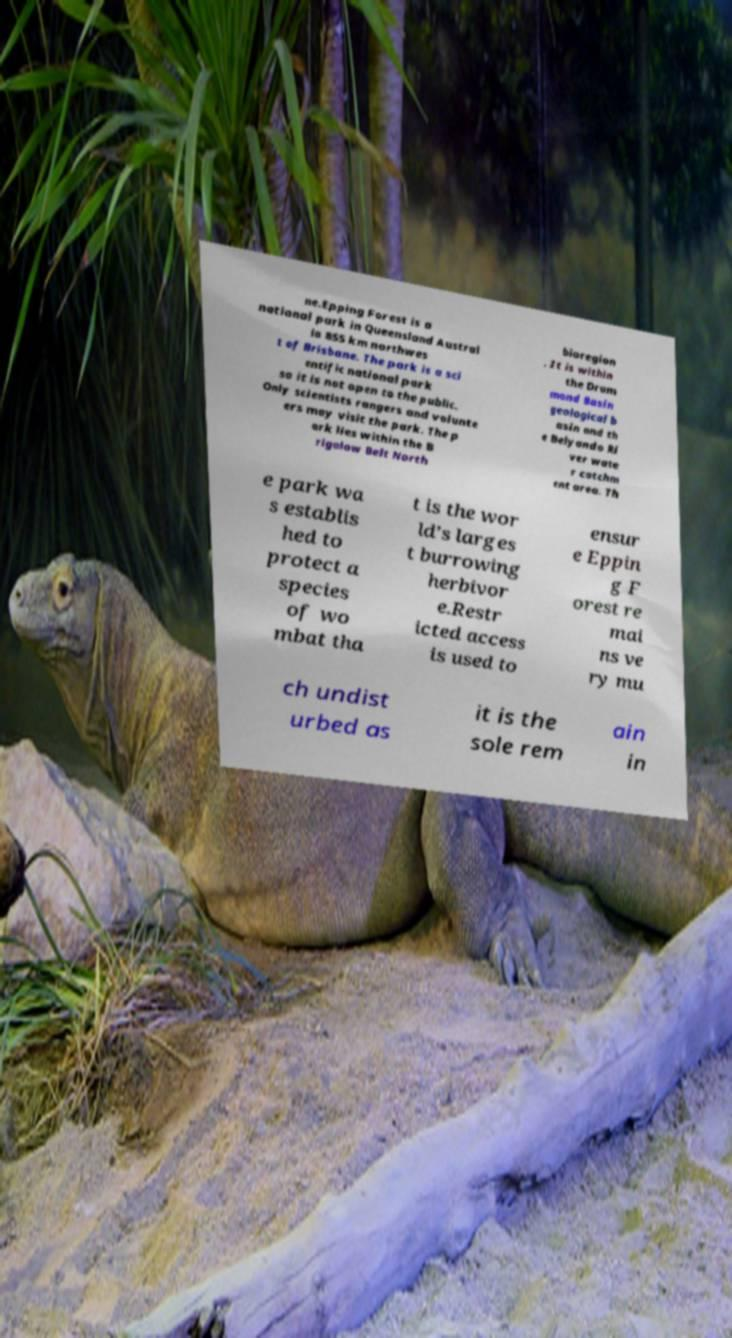Can you read and provide the text displayed in the image?This photo seems to have some interesting text. Can you extract and type it out for me? ne.Epping Forest is a national park in Queensland Austral ia 855 km northwes t of Brisbane. The park is a sci entific national park so it is not open to the public. Only scientists rangers and volunte ers may visit the park. The p ark lies within the B rigalow Belt North bioregion . It is within the Drum mond Basin geological b asin and th e Belyando Ri ver wate r catchm ent area. Th e park wa s establis hed to protect a species of wo mbat tha t is the wor ld’s larges t burrowing herbivor e.Restr icted access is used to ensur e Eppin g F orest re mai ns ve ry mu ch undist urbed as it is the sole rem ain in 